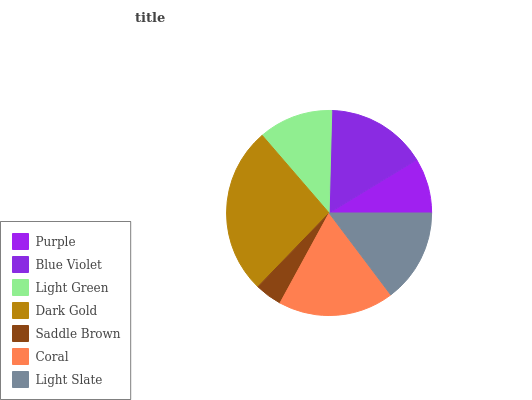Is Saddle Brown the minimum?
Answer yes or no. Yes. Is Dark Gold the maximum?
Answer yes or no. Yes. Is Blue Violet the minimum?
Answer yes or no. No. Is Blue Violet the maximum?
Answer yes or no. No. Is Blue Violet greater than Purple?
Answer yes or no. Yes. Is Purple less than Blue Violet?
Answer yes or no. Yes. Is Purple greater than Blue Violet?
Answer yes or no. No. Is Blue Violet less than Purple?
Answer yes or no. No. Is Light Slate the high median?
Answer yes or no. Yes. Is Light Slate the low median?
Answer yes or no. Yes. Is Purple the high median?
Answer yes or no. No. Is Light Green the low median?
Answer yes or no. No. 